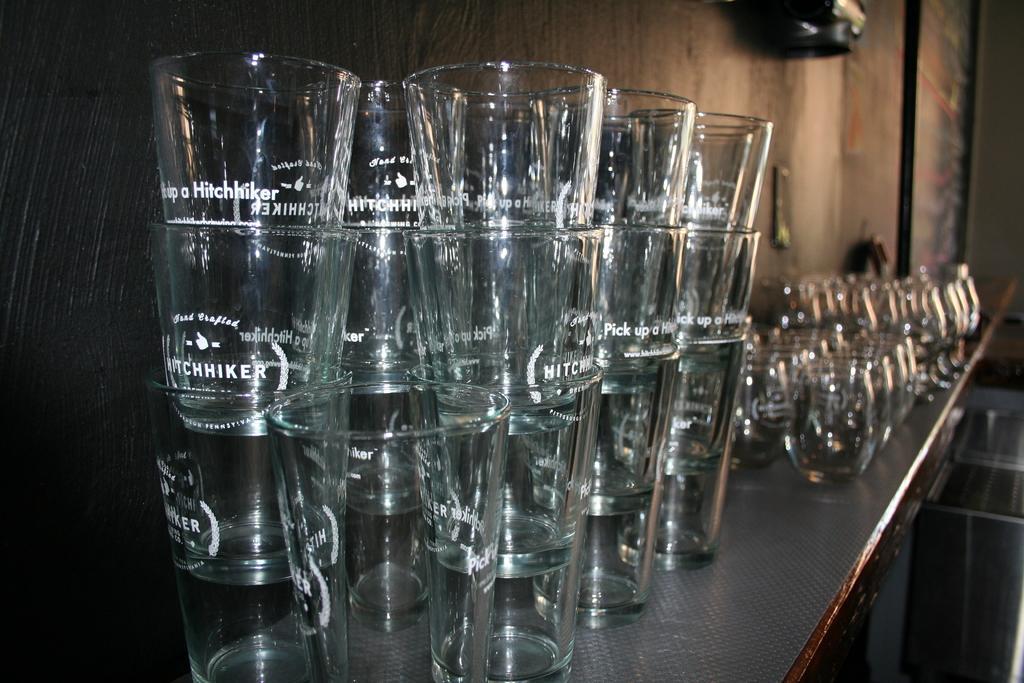In one or two sentences, can you explain what this image depicts? In the center of the image we can see one table. On the table, we can see glasses, jars and a few other objects. On the glasses, we can see some text. In the background there is a wooden wall, black color object, frame and a few other objects. 